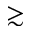Convert formula to latex. <formula><loc_0><loc_0><loc_500><loc_500>\gtrsim</formula> 